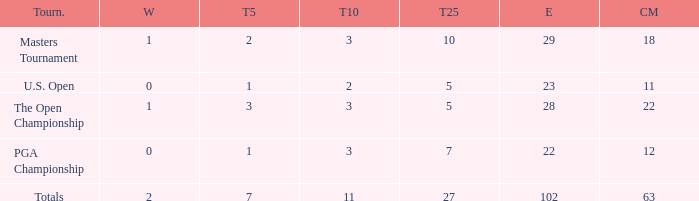How many top 10s associated with 3 top 5s and under 22 cuts made? None. 